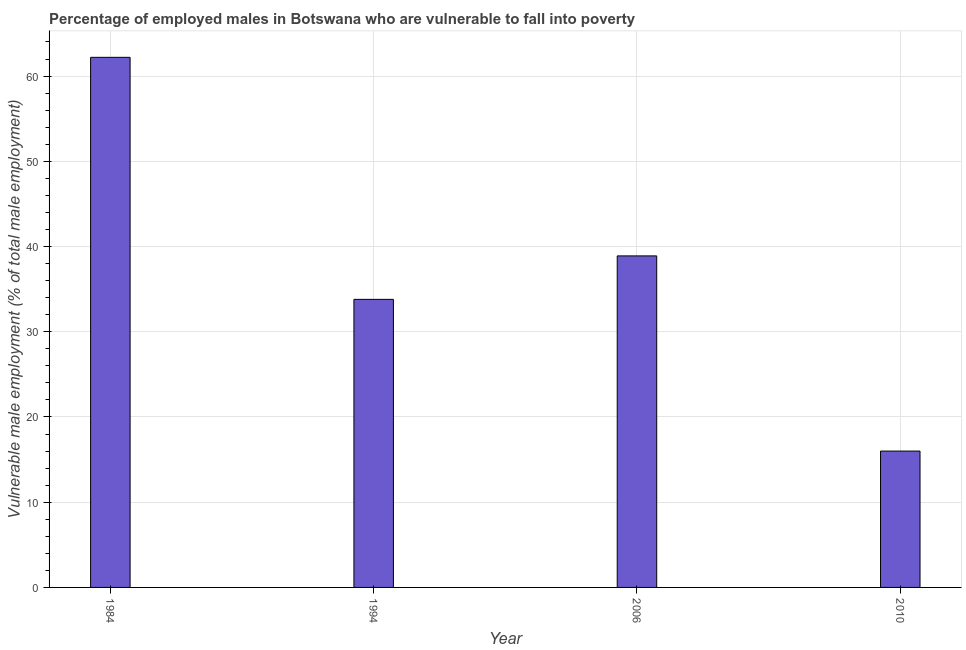What is the title of the graph?
Your answer should be compact. Percentage of employed males in Botswana who are vulnerable to fall into poverty. What is the label or title of the Y-axis?
Your answer should be compact. Vulnerable male employment (% of total male employment). What is the percentage of employed males who are vulnerable to fall into poverty in 1984?
Ensure brevity in your answer.  62.2. Across all years, what is the maximum percentage of employed males who are vulnerable to fall into poverty?
Offer a very short reply. 62.2. In which year was the percentage of employed males who are vulnerable to fall into poverty maximum?
Keep it short and to the point. 1984. In which year was the percentage of employed males who are vulnerable to fall into poverty minimum?
Ensure brevity in your answer.  2010. What is the sum of the percentage of employed males who are vulnerable to fall into poverty?
Your answer should be very brief. 150.9. What is the difference between the percentage of employed males who are vulnerable to fall into poverty in 1984 and 2006?
Your answer should be very brief. 23.3. What is the average percentage of employed males who are vulnerable to fall into poverty per year?
Offer a terse response. 37.73. What is the median percentage of employed males who are vulnerable to fall into poverty?
Provide a succinct answer. 36.35. In how many years, is the percentage of employed males who are vulnerable to fall into poverty greater than 48 %?
Ensure brevity in your answer.  1. What is the ratio of the percentage of employed males who are vulnerable to fall into poverty in 1984 to that in 2010?
Give a very brief answer. 3.89. Is the difference between the percentage of employed males who are vulnerable to fall into poverty in 2006 and 2010 greater than the difference between any two years?
Provide a short and direct response. No. What is the difference between the highest and the second highest percentage of employed males who are vulnerable to fall into poverty?
Offer a terse response. 23.3. Is the sum of the percentage of employed males who are vulnerable to fall into poverty in 2006 and 2010 greater than the maximum percentage of employed males who are vulnerable to fall into poverty across all years?
Provide a succinct answer. No. What is the difference between the highest and the lowest percentage of employed males who are vulnerable to fall into poverty?
Your answer should be very brief. 46.2. How many bars are there?
Give a very brief answer. 4. Are all the bars in the graph horizontal?
Your response must be concise. No. What is the difference between two consecutive major ticks on the Y-axis?
Keep it short and to the point. 10. What is the Vulnerable male employment (% of total male employment) of 1984?
Provide a short and direct response. 62.2. What is the Vulnerable male employment (% of total male employment) in 1994?
Your response must be concise. 33.8. What is the Vulnerable male employment (% of total male employment) in 2006?
Offer a very short reply. 38.9. What is the Vulnerable male employment (% of total male employment) of 2010?
Ensure brevity in your answer.  16. What is the difference between the Vulnerable male employment (% of total male employment) in 1984 and 1994?
Provide a short and direct response. 28.4. What is the difference between the Vulnerable male employment (% of total male employment) in 1984 and 2006?
Offer a terse response. 23.3. What is the difference between the Vulnerable male employment (% of total male employment) in 1984 and 2010?
Offer a terse response. 46.2. What is the difference between the Vulnerable male employment (% of total male employment) in 2006 and 2010?
Offer a terse response. 22.9. What is the ratio of the Vulnerable male employment (% of total male employment) in 1984 to that in 1994?
Keep it short and to the point. 1.84. What is the ratio of the Vulnerable male employment (% of total male employment) in 1984 to that in 2006?
Your response must be concise. 1.6. What is the ratio of the Vulnerable male employment (% of total male employment) in 1984 to that in 2010?
Your response must be concise. 3.89. What is the ratio of the Vulnerable male employment (% of total male employment) in 1994 to that in 2006?
Offer a terse response. 0.87. What is the ratio of the Vulnerable male employment (% of total male employment) in 1994 to that in 2010?
Offer a very short reply. 2.11. What is the ratio of the Vulnerable male employment (% of total male employment) in 2006 to that in 2010?
Your response must be concise. 2.43. 